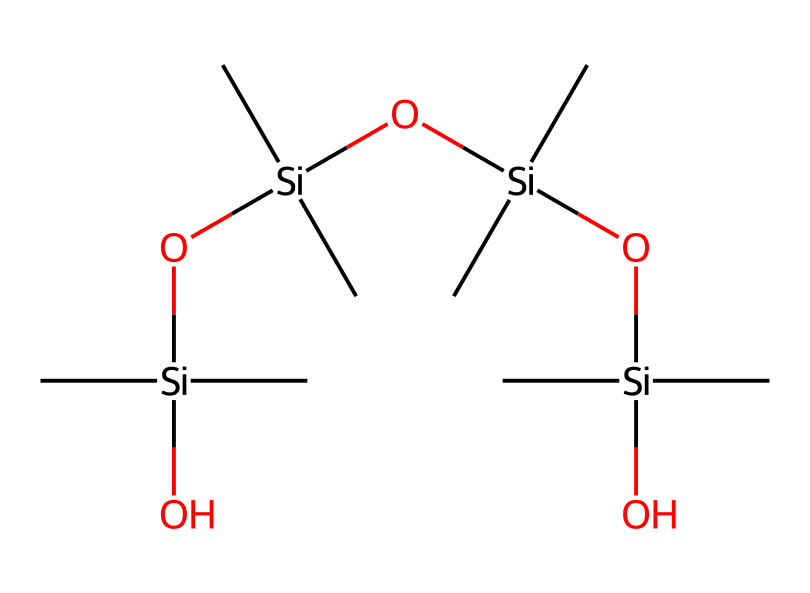how many silicon atoms are present in this structure? By examining the SMILES representation, we can identify the distinct silicon (Si) atoms. The notation "Si" appears four times explicitly within the representation, indicating that there are four silicon atoms total.
Answer: four what is the primary functional group present in polydimethylsiloxane? In the given SMILES, the presence of the -O- (oxygen) between the silicon atoms indicates the siloxane linkage, which is a characteristic functional group of polydimethylsiloxane.
Answer: siloxane how many methyl groups are attached to each silicon atom? The representation shows that each silicon atom has two methyl (C) groups attached, as indicated by the "C" symbols directly connected to each "Si".
Answer: two what type of polymer is represented by this chemical structure? The linear arrangement of repeating siloxane units (Si-O) and methyl groups characterizes this polymer as a silicone polymer, highlighting its unique properties such as flexibility and biocompatibility.
Answer: silicone does this chemical structure suggest flexibility? The alternating arrangement of silicon and oxygen, along with the methyl substituents, allows for free rotation around the Si-O bonds. This feature typically results in a flexible material, essential for medical applications such as implants.
Answer: yes how many oxygen atoms are present in the molecule? Analyzing the SMILES representation reveals that there are three oxygen atoms linked between the silicon atoms, as indicated by the "O" in the sequence.
Answer: three 